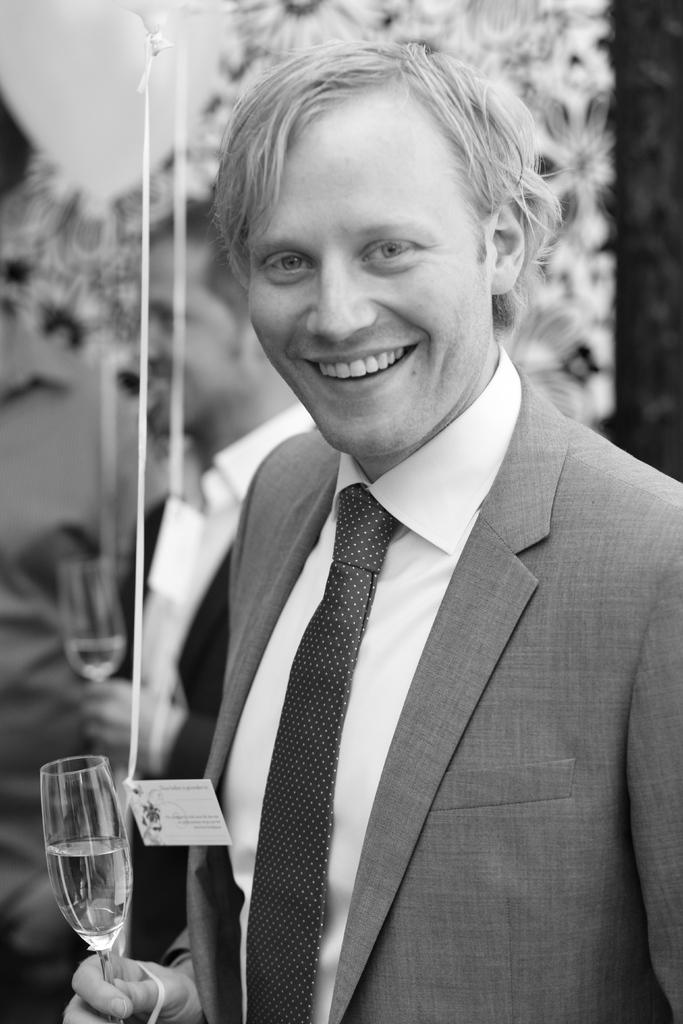What is the man in the image doing with his hand? The man is holding a glass with his hand. What is the expression on the man's face? The man is smiling. What can be seen on the man's shirt? The man has a badge on his shirt. Can you describe the second man in the image? There is another man in the background of the image, and he is holding a glass. What type of humor is the man in the image using to entertain the audience? There is no indication in the image that the man is using humor to entertain an audience. 